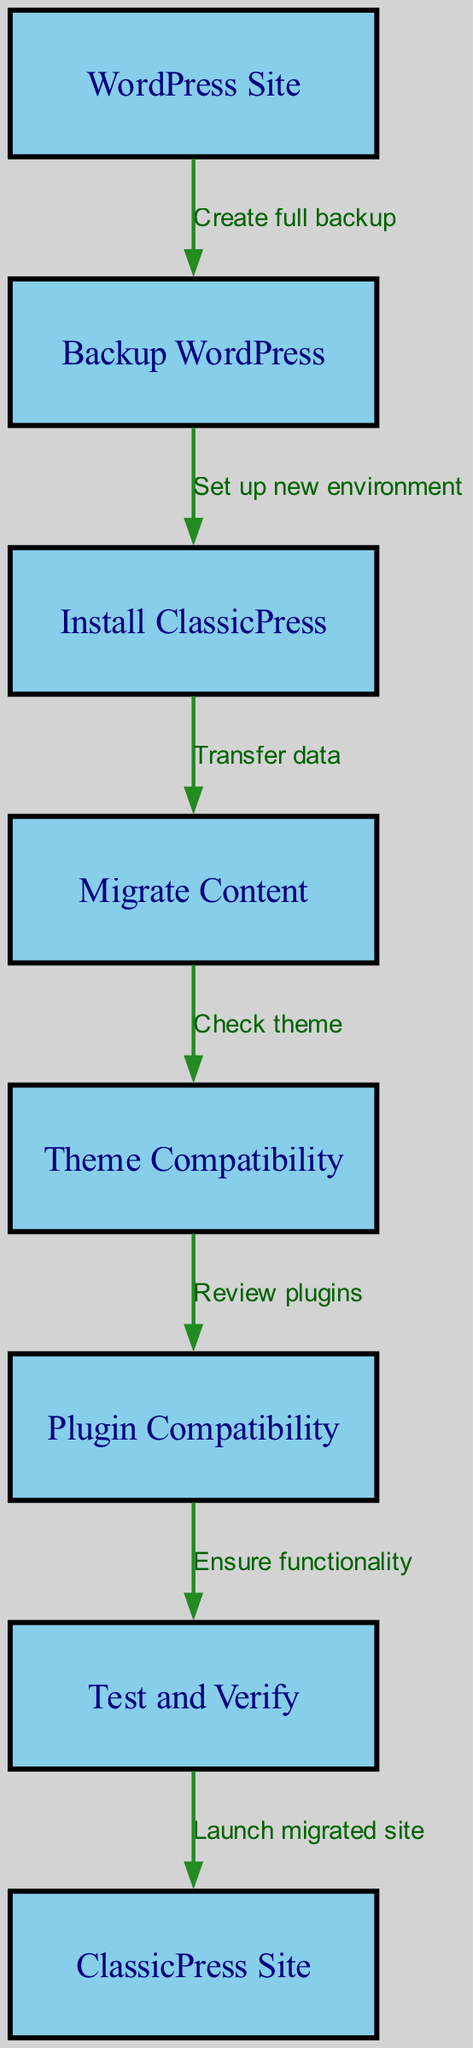What is the first step in the migration process? The first node in the diagram is "WordPress Site," which represents the starting point of the migration process. The edge leading from this node to the next indicates a transition to taking backup.
Answer: Backup WordPress How many nodes are present in the diagram? By counting the nodes in the provided data, there are a total of eight unique nodes representing different stages of the migration process.
Answer: 8 What is the relationship between “Migrate Content” and “Install ClassicPress”? The edge leading from "Install ClassicPress" to "Migrate Content" indicates that "Transfer data" is the label. This signifies that migrating content happens after the installation of ClassicPress.
Answer: Transfer data What node follows "Test and Verify"? Following the "Test and Verify" node based on the edges in the diagram, the next node is "ClassicPress Site," showcasing the conclusion of the migration process.
Answer: ClassicPress Site How many edges connect the nodes in the diagram? Counting all the edges in the data reveals that there are a total of seven edges representing the transitions between the different migration stages from WordPress to ClassicPress.
Answer: 7 Which node checks theme compatibility? The node that checks the compatibility of themes is labeled "Theme Compatibility." This node specifically follows the "Migrate Content" node in the migration flow.
Answer: Theme Compatibility What is the last action in the migration process? The last action represented in the diagram is labeled "Launch migrated site," which signifies the final step of the migration where the ClassicPress site goes live.
Answer: Launch migrated site How does the migration process start? The migration process begins at the "WordPress Site" node, which is where the initial action of creating a backup is performed to safeguard existing data.
Answer: Create full backup 